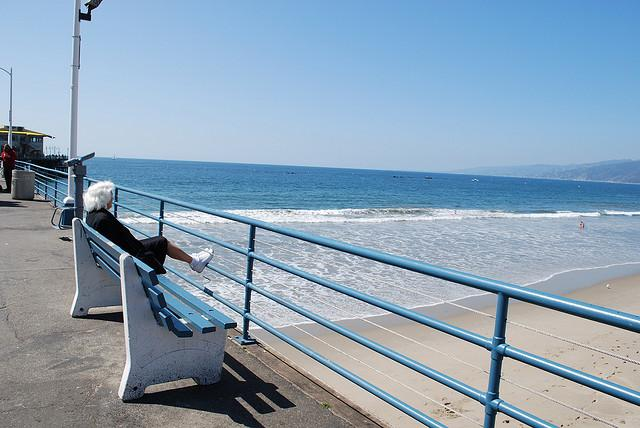What is the name of the structure the bench is sitting on?

Choices:
A) ramp
B) pier
C) dais
D) island pier 